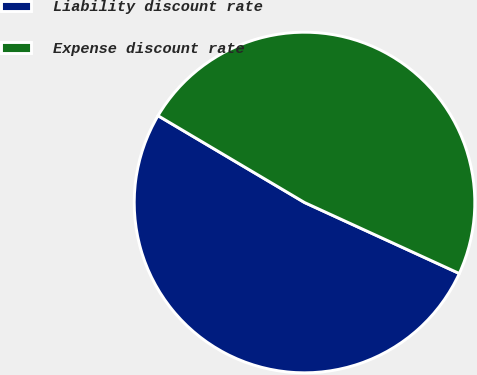Convert chart to OTSL. <chart><loc_0><loc_0><loc_500><loc_500><pie_chart><fcel>Liability discount rate<fcel>Expense discount rate<nl><fcel>51.67%<fcel>48.33%<nl></chart> 